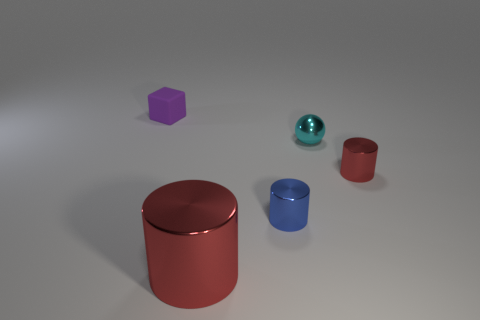What shape is the large thing that is the same material as the tiny ball?
Offer a terse response. Cylinder. There is a cyan thing behind the object on the right side of the metal object that is behind the small red cylinder; what is its shape?
Give a very brief answer. Sphere. Is the number of large cyan shiny cylinders greater than the number of cyan things?
Provide a succinct answer. No. There is another blue thing that is the same shape as the big metal object; what is its material?
Provide a short and direct response. Metal. Is the purple object made of the same material as the tiny cyan object?
Your answer should be compact. No. Is the number of cylinders that are in front of the sphere greater than the number of large metal cylinders?
Ensure brevity in your answer.  Yes. What material is the red cylinder that is in front of the small cylinder that is in front of the red cylinder right of the big object made of?
Offer a very short reply. Metal. How many objects are tiny rubber objects or tiny metallic things that are on the left side of the cyan ball?
Your response must be concise. 2. Does the small thing to the left of the big metallic thing have the same color as the large cylinder?
Provide a short and direct response. No. Are there more cyan objects to the right of the small block than small cyan spheres behind the cyan ball?
Keep it short and to the point. Yes. 